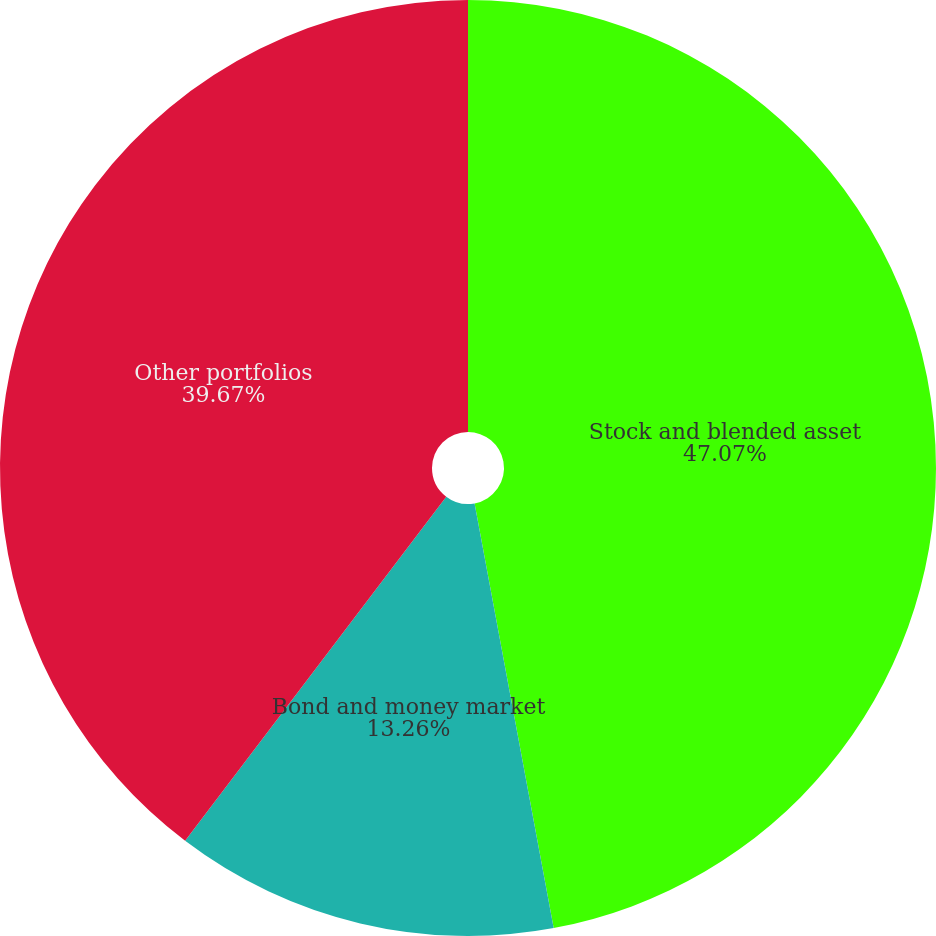Convert chart to OTSL. <chart><loc_0><loc_0><loc_500><loc_500><pie_chart><fcel>Stock and blended asset<fcel>Bond and money market<fcel>Other portfolios<nl><fcel>47.07%<fcel>13.26%<fcel>39.67%<nl></chart> 